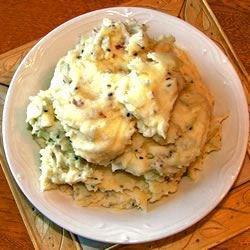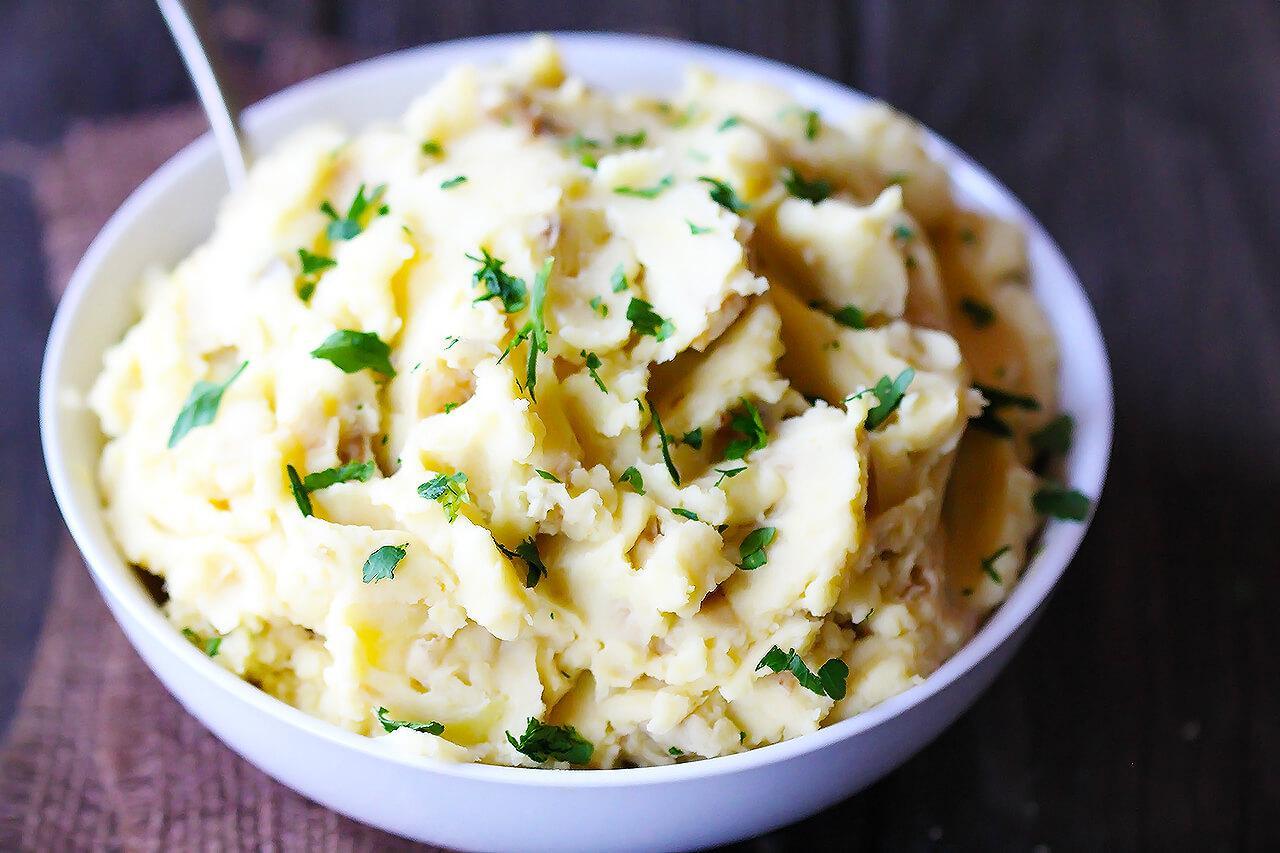The first image is the image on the left, the second image is the image on the right. Given the left and right images, does the statement "A handle is sticking out of the round bowl of potatoes in the right image." hold true? Answer yes or no. Yes. 